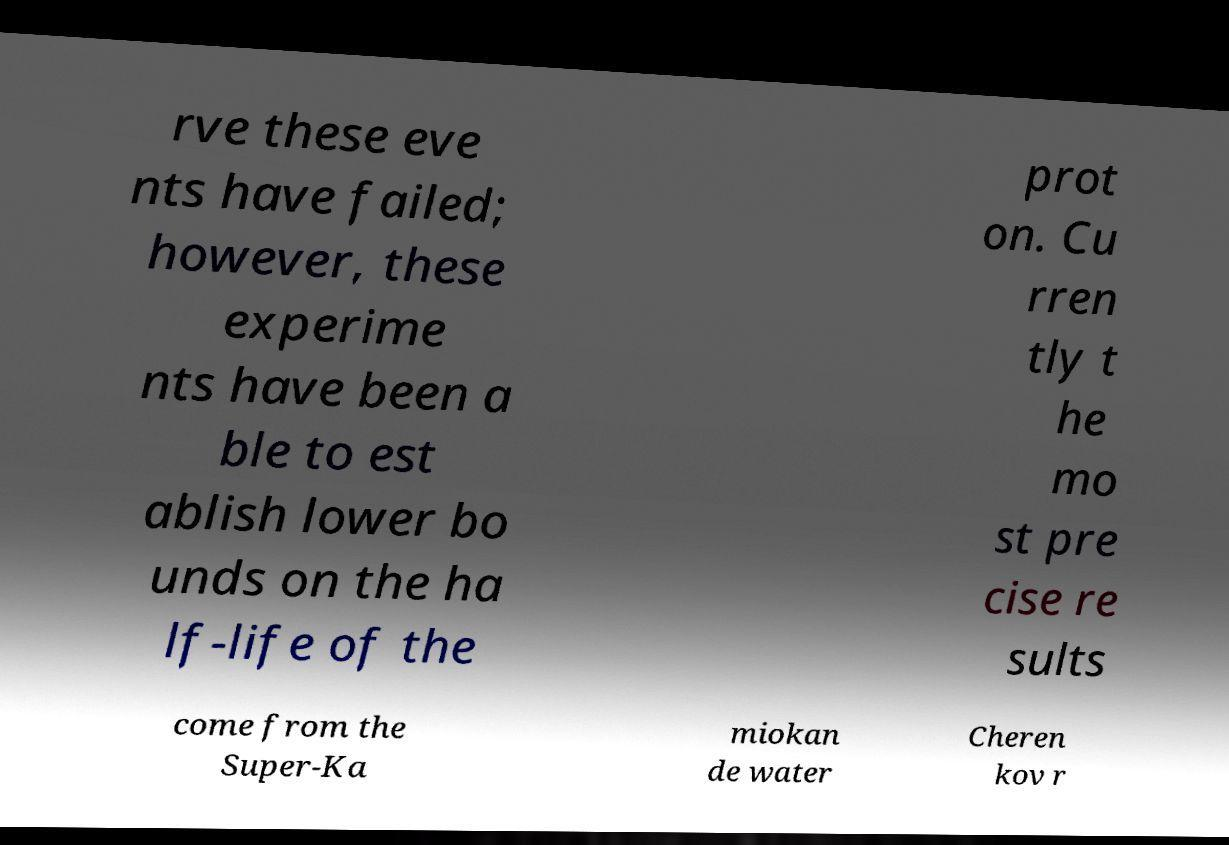Please read and relay the text visible in this image. What does it say? rve these eve nts have failed; however, these experime nts have been a ble to est ablish lower bo unds on the ha lf-life of the prot on. Cu rren tly t he mo st pre cise re sults come from the Super-Ka miokan de water Cheren kov r 